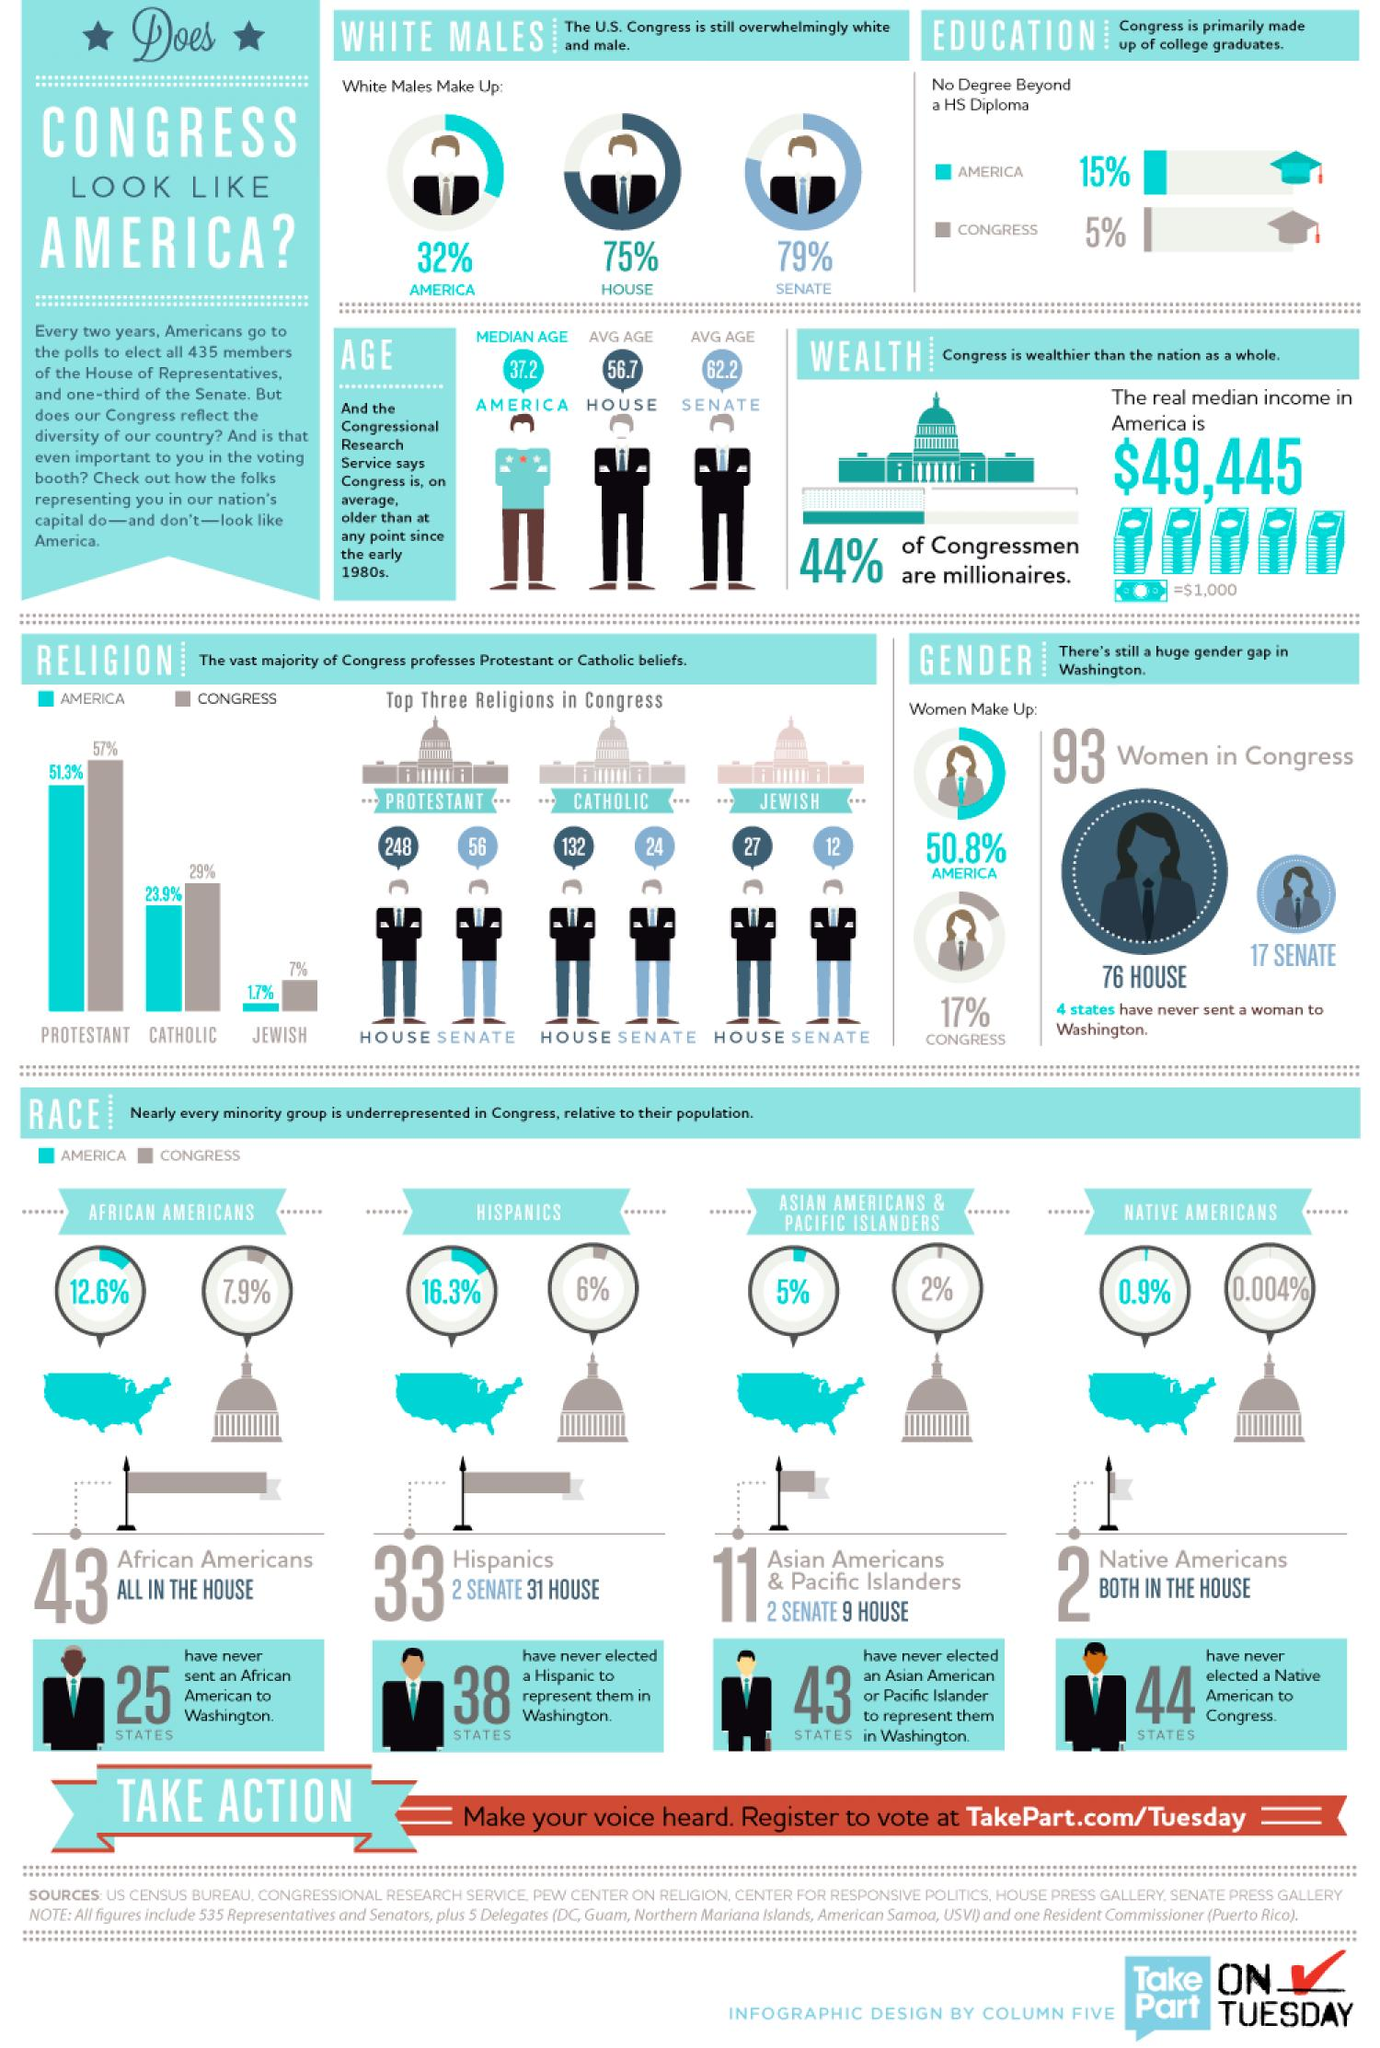Identify some key points in this picture. According to recent estimates, only 0.9% of the American population self-identifies as Native American. There are 56 Protestants in the Senate. There are 12 Jewish people in the Senate. Approximately 17% of the current Congress is comprised of women. Hispanics make up 16.3% of the total population of the United States. 